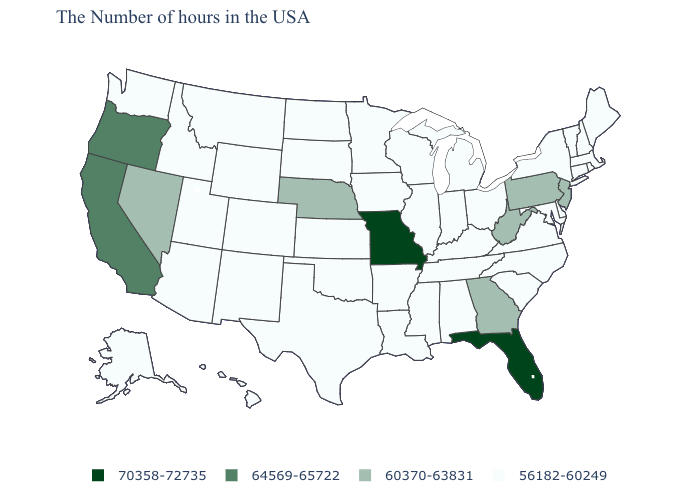Is the legend a continuous bar?
Keep it brief. No. What is the lowest value in states that border Oregon?
Answer briefly. 56182-60249. What is the highest value in the USA?
Give a very brief answer. 70358-72735. Name the states that have a value in the range 56182-60249?
Write a very short answer. Maine, Massachusetts, Rhode Island, New Hampshire, Vermont, Connecticut, New York, Delaware, Maryland, Virginia, North Carolina, South Carolina, Ohio, Michigan, Kentucky, Indiana, Alabama, Tennessee, Wisconsin, Illinois, Mississippi, Louisiana, Arkansas, Minnesota, Iowa, Kansas, Oklahoma, Texas, South Dakota, North Dakota, Wyoming, Colorado, New Mexico, Utah, Montana, Arizona, Idaho, Washington, Alaska, Hawaii. Name the states that have a value in the range 56182-60249?
Concise answer only. Maine, Massachusetts, Rhode Island, New Hampshire, Vermont, Connecticut, New York, Delaware, Maryland, Virginia, North Carolina, South Carolina, Ohio, Michigan, Kentucky, Indiana, Alabama, Tennessee, Wisconsin, Illinois, Mississippi, Louisiana, Arkansas, Minnesota, Iowa, Kansas, Oklahoma, Texas, South Dakota, North Dakota, Wyoming, Colorado, New Mexico, Utah, Montana, Arizona, Idaho, Washington, Alaska, Hawaii. Name the states that have a value in the range 64569-65722?
Concise answer only. California, Oregon. Does Louisiana have the lowest value in the South?
Keep it brief. Yes. Does South Carolina have the lowest value in the South?
Keep it brief. Yes. How many symbols are there in the legend?
Concise answer only. 4. Among the states that border Florida , which have the highest value?
Concise answer only. Georgia. What is the lowest value in states that border Montana?
Answer briefly. 56182-60249. Does Florida have the highest value in the USA?
Be succinct. Yes. Among the states that border Alabama , which have the highest value?
Concise answer only. Florida. Among the states that border Florida , does Alabama have the highest value?
Be succinct. No. What is the value of Massachusetts?
Concise answer only. 56182-60249. 